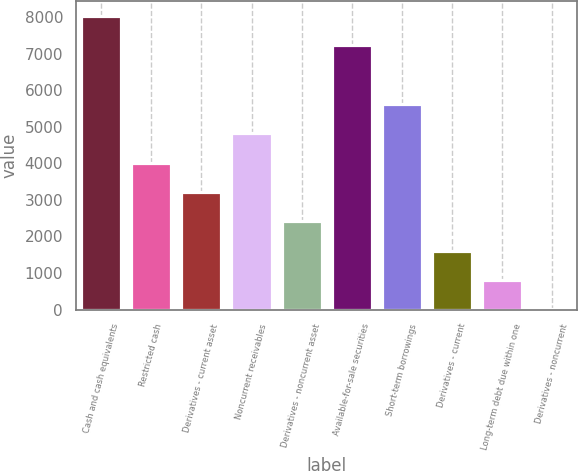Convert chart. <chart><loc_0><loc_0><loc_500><loc_500><bar_chart><fcel>Cash and cash equivalents<fcel>Restricted cash<fcel>Derivatives - current asset<fcel>Noncurrent receivables<fcel>Derivatives - noncurrent asset<fcel>Available-for-sale securities<fcel>Short-term borrowings<fcel>Derivatives - current<fcel>Long-term debt due within one<fcel>Derivatives - noncurrent<nl><fcel>8044<fcel>4023.5<fcel>3219.4<fcel>4827.6<fcel>2415.3<fcel>7239.9<fcel>5631.7<fcel>1611.2<fcel>807.1<fcel>3<nl></chart> 